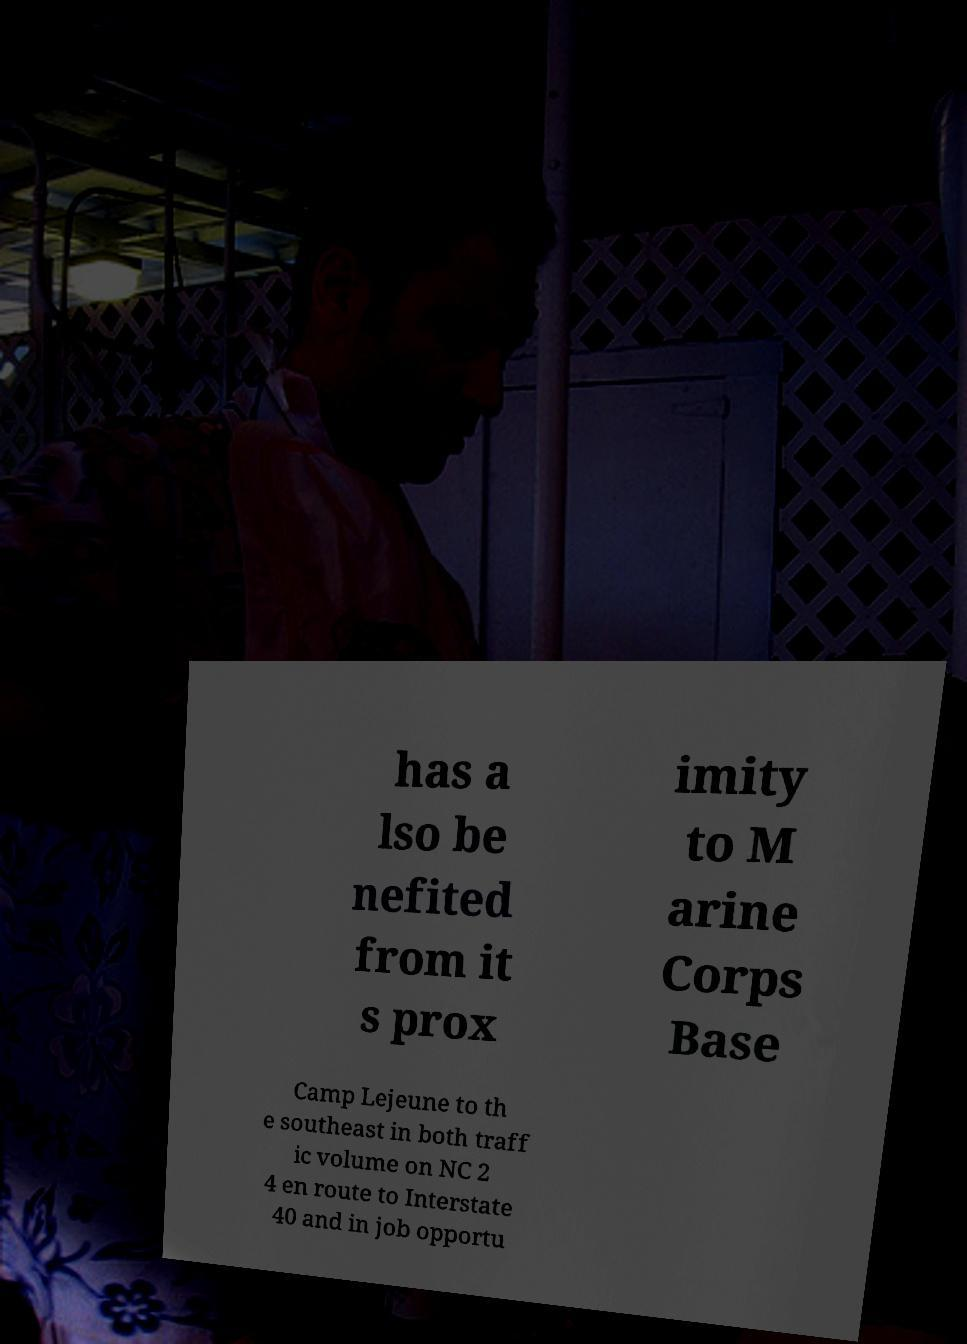Please identify and transcribe the text found in this image. has a lso be nefited from it s prox imity to M arine Corps Base Camp Lejeune to th e southeast in both traff ic volume on NC 2 4 en route to Interstate 40 and in job opportu 